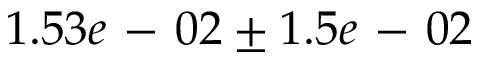Convert formula to latex. <formula><loc_0><loc_0><loc_500><loc_500>1 . 5 3 e - 0 2 \pm 1 . 5 e - 0 2</formula> 